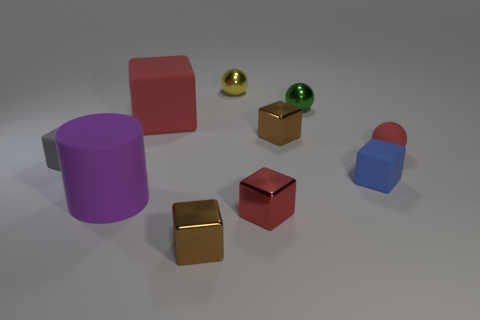There is a small cube that is the same color as the large matte cube; what material is it?
Your answer should be very brief. Metal. What number of balls are small green metal objects or small metallic objects?
Provide a succinct answer. 2. Does the tiny blue rubber thing have the same shape as the green metal thing?
Your response must be concise. No. There is a matte object behind the red ball; what size is it?
Ensure brevity in your answer.  Large. Are there any small rubber blocks that have the same color as the big cylinder?
Your answer should be very brief. No. There is a red rubber thing on the left side of the red rubber ball; is its size the same as the green ball?
Your response must be concise. No. What color is the big rubber cube?
Your answer should be very brief. Red. There is a thing that is to the right of the tiny blue thing on the right side of the gray matte object; what color is it?
Provide a short and direct response. Red. Are there any large things made of the same material as the yellow ball?
Your response must be concise. No. What is the material of the blue object that is on the right side of the small brown metallic block to the left of the small yellow shiny object?
Keep it short and to the point. Rubber. 